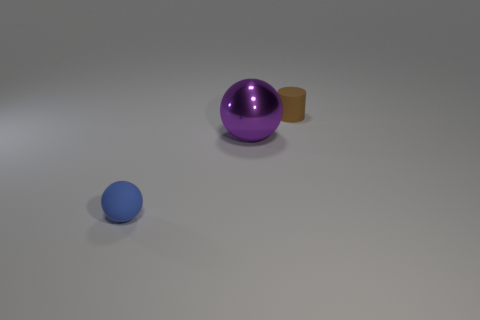What size is the metallic thing left of the matte cylinder?
Provide a succinct answer. Large. What material is the big thing?
Provide a succinct answer. Metal. There is a tiny thing that is in front of the cylinder; does it have the same shape as the large metal thing?
Your response must be concise. Yes. Are there any things of the same size as the cylinder?
Keep it short and to the point. Yes. Is there a tiny sphere that is in front of the small object that is on the right side of the tiny matte thing in front of the cylinder?
Keep it short and to the point. Yes. There is a big ball; is it the same color as the small rubber thing that is right of the shiny ball?
Offer a terse response. No. There is a tiny object on the left side of the rubber thing to the right of the metal object behind the small blue object; what is it made of?
Keep it short and to the point. Rubber. There is a object behind the purple metal thing; what shape is it?
Your answer should be compact. Cylinder. The thing that is the same material as the brown cylinder is what size?
Give a very brief answer. Small. What number of small green things are the same shape as the big metallic thing?
Make the answer very short. 0. 